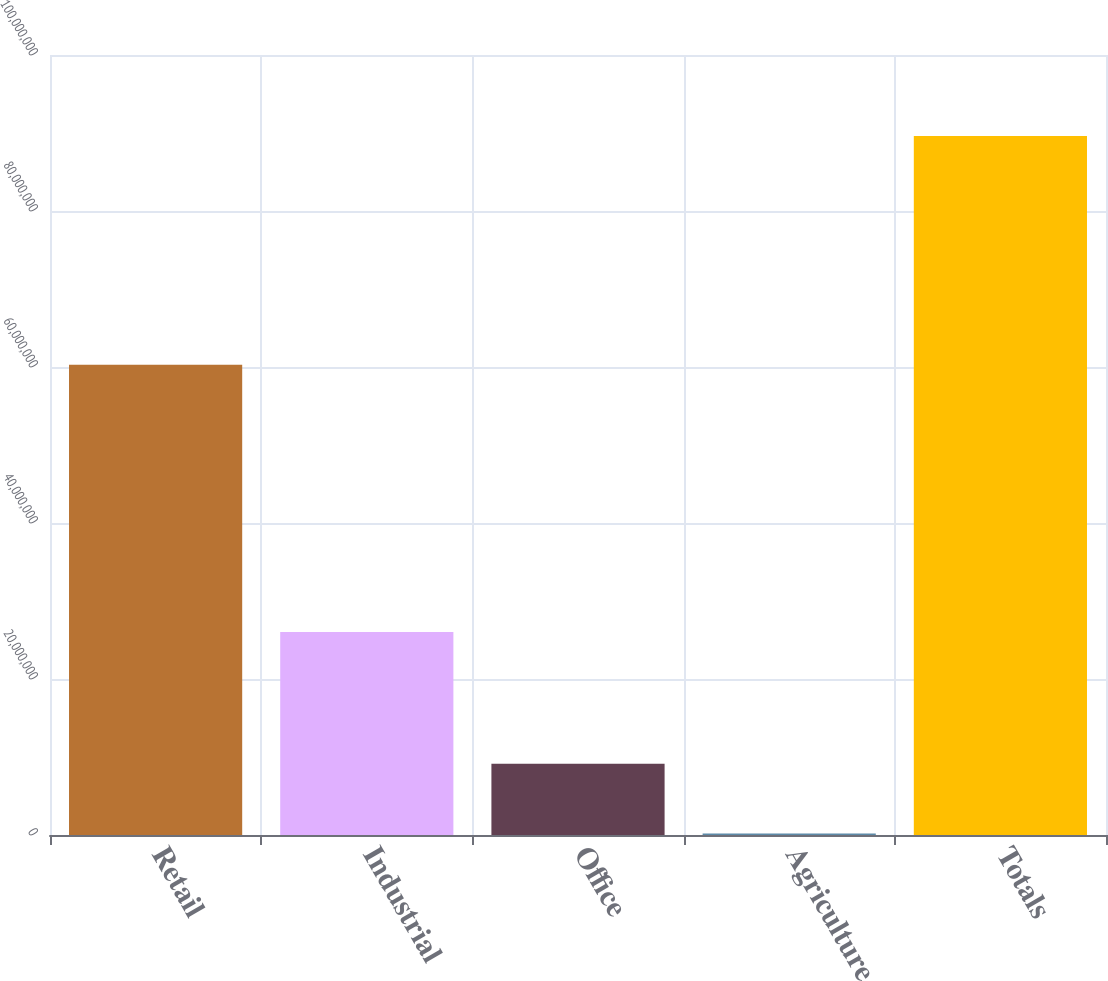Convert chart to OTSL. <chart><loc_0><loc_0><loc_500><loc_500><bar_chart><fcel>Retail<fcel>Industrial<fcel>Office<fcel>Agriculture<fcel>Totals<nl><fcel>6.02895e+07<fcel>2.60234e+07<fcel>9.12626e+06<fcel>184500<fcel>8.96021e+07<nl></chart> 